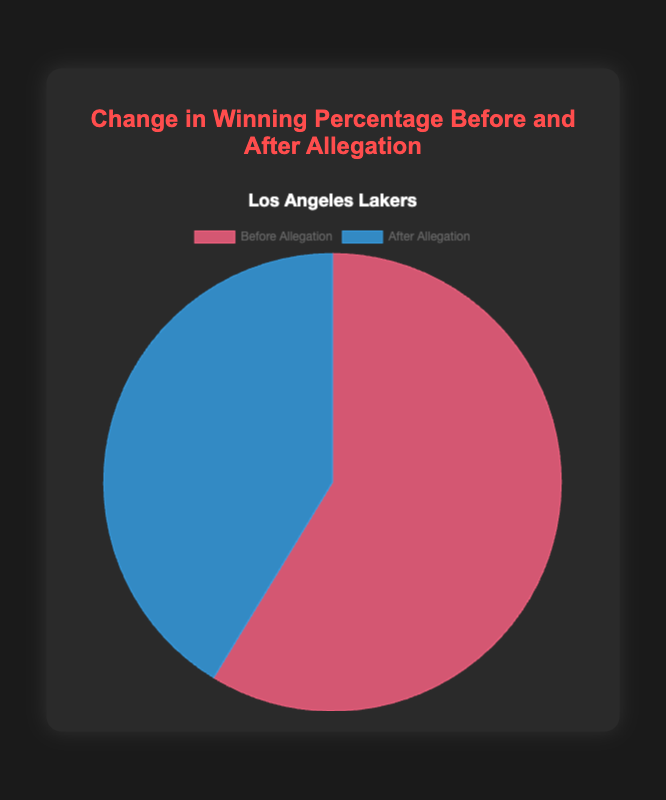Which team's winning percentage changed more drastically after the allegation? Compare the difference in winning percentages before and after the allegation for both teams. For the Los Angeles Lakers, it went from 75.6% to 53.2%, a difference of 22.4%. For Manchester United, it went from 68.4% to 52.8%, a difference of 15.6%. The Los Angeles Lakers had a more drastic change.
Answer: Los Angeles Lakers What is the percentage decrease in winning percentage for the Los Angeles Lakers after the allegation? Calculate the decrease in winning percentage (75.6% - 53.2%) and then calculate the percentage decrease ((Decrease / Original) * 100) = ((22.4 / 75.6) * 100). This simplifies to approximately 29.63%.
Answer: 29.63% What is the overall winning percentage before the allegation for both teams combined? Add the winning percentages of both teams before the allegation (75.6% + 68.4%). This results in a total of 144%.
Answer: 144% What is the difference in the percentage points of the winning percentage before and after the allegation for Manchester United? Subtract the after allegation percentage from the before allegation percentage for Manchester United (68.4% - 52.8%). This results in 15.6 percentage points.
Answer: 15.6 Which team had a higher winning percentage after the allegation? Compare the winning percentages after the allegation for both teams. Manchester United had 52.8%, and the Los Angeles Lakers had 53.2%. The Los Angeles Lakers had a higher percentage.
Answer: Los Angeles Lakers What is the average winning percentage after the allegation for both teams? Calculate the average of winning percentages after the allegation for both teams ((53.2% + 52.8%) / 2). This equals 53%.
Answer: 53% How much lower is Manchester United's winning percentage after the allegation than the Los Angeles Lakers' winning percentage before the allegation? Subtract Manchester United's after allegation percentage (52.8%) from the Los Angeles Lakers' before allegation percentage (75.6%). This equals 22.8 percentage points.
Answer: 22.8 What proportion of the entire pie chart does the "Before Allegation" segment for the Los Angeles Lakers represent? The chart contains two segments for the Los Angeles Lakers: Before Allegation (75.6%) and After Allegation (53.2%). The "Before Allegation" segment represents approximately 75.6 / (75.6 + 53.2) ≈ 58.7%.
Answer: 58.7% 